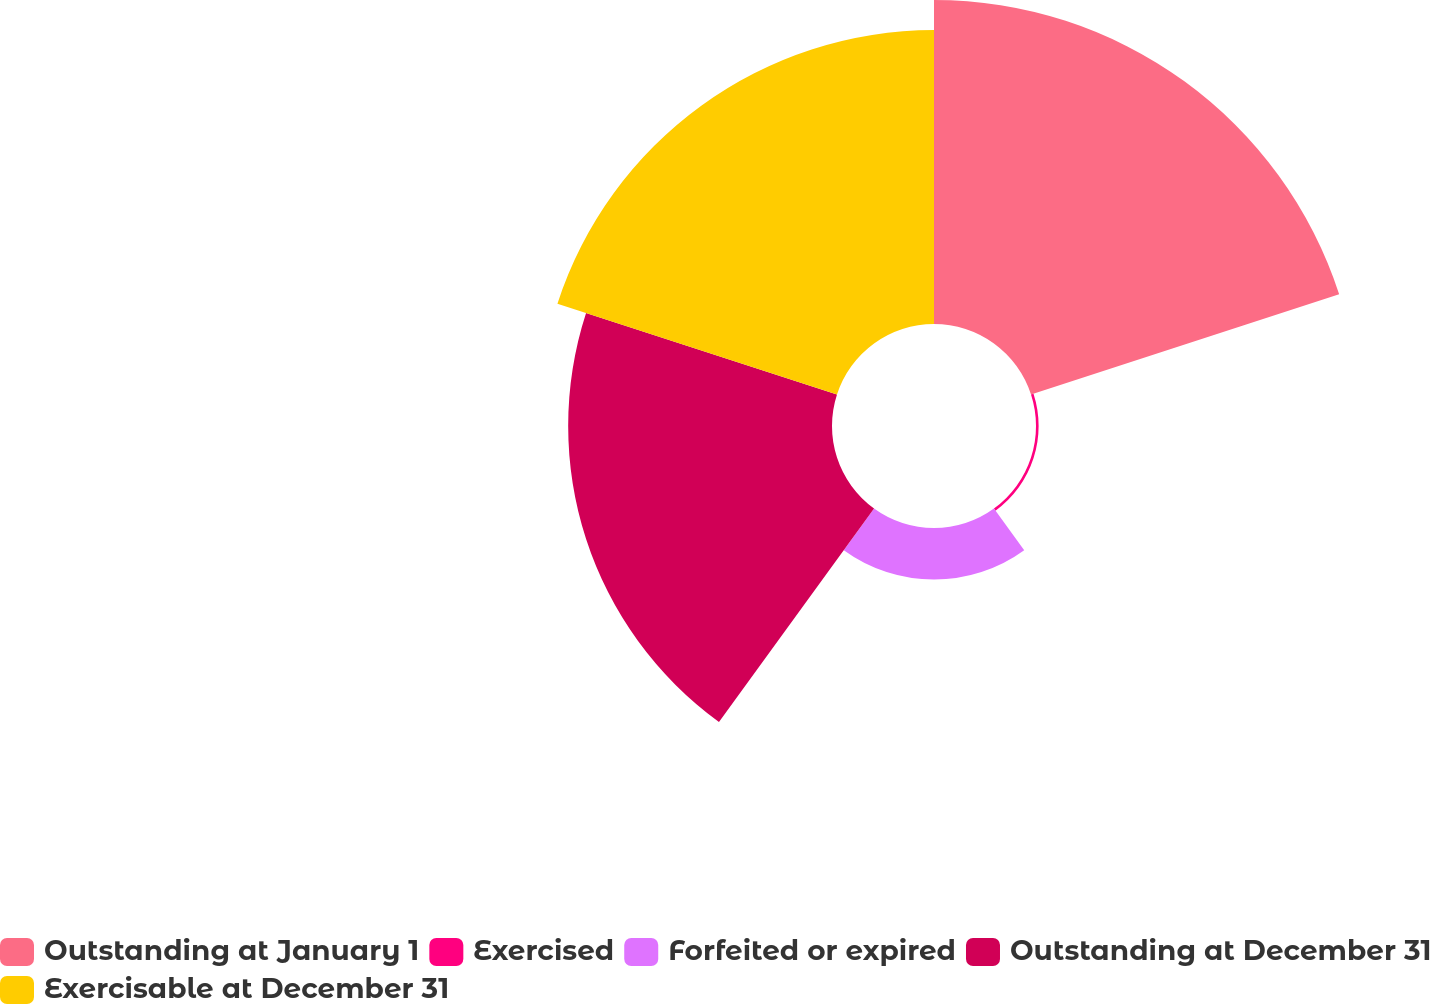Convert chart to OTSL. <chart><loc_0><loc_0><loc_500><loc_500><pie_chart><fcel>Outstanding at January 1<fcel>Exercised<fcel>Forfeited or expired<fcel>Outstanding at December 31<fcel>Exercisable at December 31<nl><fcel>34.62%<fcel>0.28%<fcel>5.5%<fcel>28.19%<fcel>31.41%<nl></chart> 